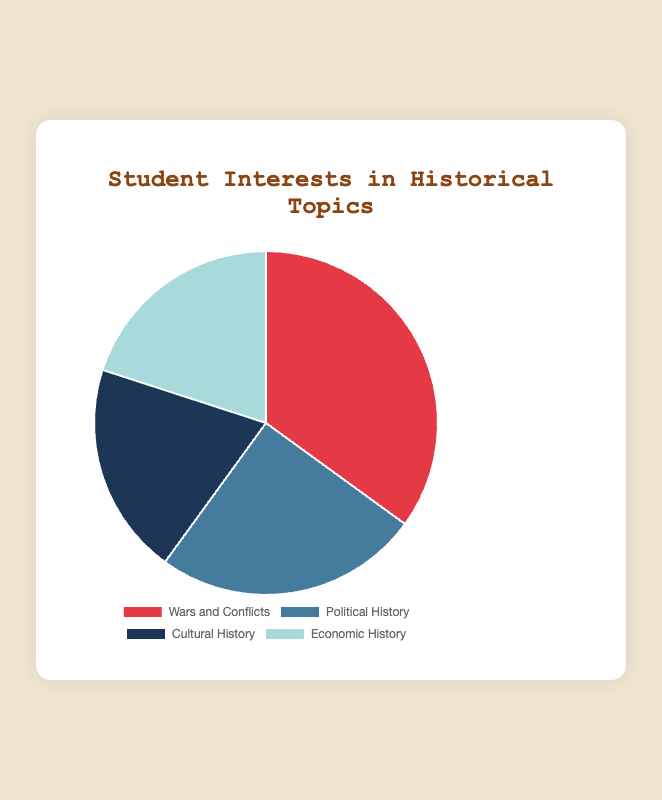What percentage of students are interested in Wars and Conflicts? From the pie chart, observe the segment labeled "Wars and Conflicts" and note down the percentage value associated with it.
Answer: 35% Which historical topic has the least interest among students? Compare the percentages of all segments in the pie chart and identify the one with the smallest value. The "Cultural History" and "Economic History" both share the smallest percentage, 20%, thus either can be considered as the correct answer.
Answer: Cultural History or Economic History By how much does interest in Wars and Conflicts exceed interest in Political History? Note the percentages for "Wars and Conflicts" (35%) and "Political History" (25%). Subtract the percentage of Political History from Wars and Conflicts: 35% - 25% = 10%.
Answer: 10% What is the combined percentage for Cultural History and Economic History? From the pie chart, find the percentages for "Cultural History" (20%) and "Economic History" (20%), and then add them together: 20% + 20% = 40%.
Answer: 40% Which topic has higher interest: Cultural History or Economic History? Observe the pie chart and compare the percentages of "Cultural History" and "Economic History." Both have the same interest percentage of 20%.
Answer: Equal What is the total percentage of students interested in topics other than Wars and Conflicts? From the pie chart, note down the percentages of other topics: Political History (25%), Cultural History (20%), and Economic History (20%). Then sum these values: 25% + 20% + 20% = 65%.
Answer: 65% Which topic has the second highest percentage of interest among students? Review the pie chart to identify the segment with the highest percentage first (Wars and Conflicts, 35%), then find the next highest, which is "Political History" with 25%.
Answer: Political History By how much does interest in Wars and Conflicts differ from interest in Cultural History? Observe the percentages from the pie chart: Wars and Conflicts (35%) and Cultural History (20%). Subtract the percentage of Cultural History from Wars and Conflicts: 35% - 20% = 15%.
Answer: 15% What is the average percentage interest of students across all four historical topics? Add the percentages of all four segments from the pie chart: 35% (Wars and Conflicts) + 25% (Political History) + 20% (Cultural History) + 20% (Economic History) = 100%. Divide this sum by the number of topics (4): 100% / 4 = 25%.
Answer: 25% What is the difference between the highest and lowest percentages of student interest in historical topics? Identify the highest percentage (Wars and Conflicts, 35%) and the lowest percentage (either Cultural History or Economic History, 20%). Subtract the lowest percentage from the highest: 35% - 20% = 15%.
Answer: 15% 